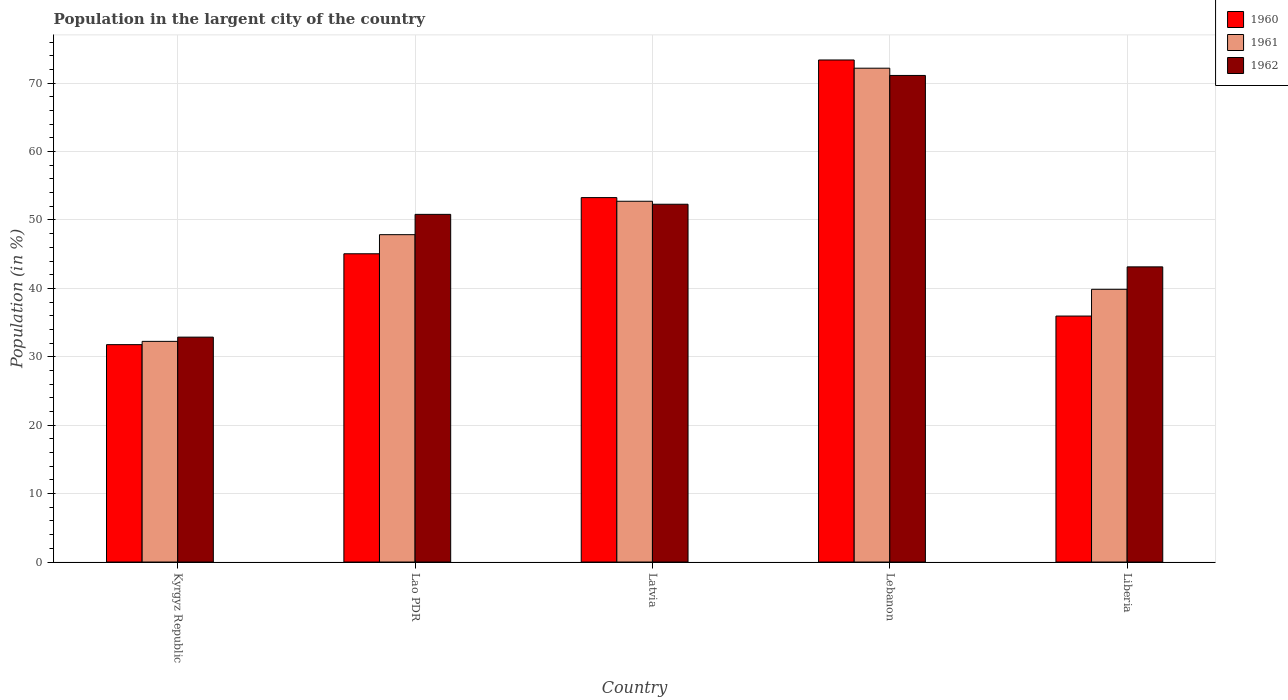How many different coloured bars are there?
Ensure brevity in your answer.  3. How many groups of bars are there?
Offer a very short reply. 5. Are the number of bars per tick equal to the number of legend labels?
Offer a very short reply. Yes. What is the label of the 1st group of bars from the left?
Keep it short and to the point. Kyrgyz Republic. In how many cases, is the number of bars for a given country not equal to the number of legend labels?
Ensure brevity in your answer.  0. What is the percentage of population in the largent city in 1962 in Latvia?
Your response must be concise. 52.3. Across all countries, what is the maximum percentage of population in the largent city in 1961?
Your answer should be compact. 72.19. Across all countries, what is the minimum percentage of population in the largent city in 1960?
Ensure brevity in your answer.  31.78. In which country was the percentage of population in the largent city in 1960 maximum?
Provide a short and direct response. Lebanon. In which country was the percentage of population in the largent city in 1962 minimum?
Provide a short and direct response. Kyrgyz Republic. What is the total percentage of population in the largent city in 1962 in the graph?
Provide a succinct answer. 250.28. What is the difference between the percentage of population in the largent city in 1960 in Lao PDR and that in Latvia?
Provide a succinct answer. -8.21. What is the difference between the percentage of population in the largent city in 1961 in Liberia and the percentage of population in the largent city in 1962 in Latvia?
Offer a terse response. -12.43. What is the average percentage of population in the largent city in 1960 per country?
Offer a very short reply. 47.89. What is the difference between the percentage of population in the largent city of/in 1961 and percentage of population in the largent city of/in 1960 in Kyrgyz Republic?
Offer a terse response. 0.48. What is the ratio of the percentage of population in the largent city in 1962 in Lao PDR to that in Liberia?
Your response must be concise. 1.18. Is the difference between the percentage of population in the largent city in 1961 in Lao PDR and Lebanon greater than the difference between the percentage of population in the largent city in 1960 in Lao PDR and Lebanon?
Keep it short and to the point. Yes. What is the difference between the highest and the second highest percentage of population in the largent city in 1960?
Give a very brief answer. 28.33. What is the difference between the highest and the lowest percentage of population in the largent city in 1960?
Provide a short and direct response. 41.61. In how many countries, is the percentage of population in the largent city in 1960 greater than the average percentage of population in the largent city in 1960 taken over all countries?
Keep it short and to the point. 2. Is the sum of the percentage of population in the largent city in 1961 in Latvia and Lebanon greater than the maximum percentage of population in the largent city in 1962 across all countries?
Make the answer very short. Yes. What does the 2nd bar from the left in Kyrgyz Republic represents?
Provide a succinct answer. 1961. How many bars are there?
Keep it short and to the point. 15. What is the difference between two consecutive major ticks on the Y-axis?
Make the answer very short. 10. Are the values on the major ticks of Y-axis written in scientific E-notation?
Keep it short and to the point. No. How many legend labels are there?
Your answer should be very brief. 3. How are the legend labels stacked?
Ensure brevity in your answer.  Vertical. What is the title of the graph?
Offer a very short reply. Population in the largent city of the country. What is the Population (in %) in 1960 in Kyrgyz Republic?
Provide a succinct answer. 31.78. What is the Population (in %) of 1961 in Kyrgyz Republic?
Keep it short and to the point. 32.26. What is the Population (in %) in 1962 in Kyrgyz Republic?
Ensure brevity in your answer.  32.88. What is the Population (in %) of 1960 in Lao PDR?
Make the answer very short. 45.06. What is the Population (in %) of 1961 in Lao PDR?
Give a very brief answer. 47.86. What is the Population (in %) of 1962 in Lao PDR?
Give a very brief answer. 50.82. What is the Population (in %) in 1960 in Latvia?
Your answer should be very brief. 53.27. What is the Population (in %) of 1961 in Latvia?
Give a very brief answer. 52.74. What is the Population (in %) of 1962 in Latvia?
Provide a succinct answer. 52.3. What is the Population (in %) of 1960 in Lebanon?
Make the answer very short. 73.39. What is the Population (in %) in 1961 in Lebanon?
Make the answer very short. 72.19. What is the Population (in %) in 1962 in Lebanon?
Ensure brevity in your answer.  71.13. What is the Population (in %) of 1960 in Liberia?
Provide a succinct answer. 35.96. What is the Population (in %) of 1961 in Liberia?
Give a very brief answer. 39.87. What is the Population (in %) of 1962 in Liberia?
Provide a succinct answer. 43.15. Across all countries, what is the maximum Population (in %) of 1960?
Make the answer very short. 73.39. Across all countries, what is the maximum Population (in %) of 1961?
Your answer should be very brief. 72.19. Across all countries, what is the maximum Population (in %) of 1962?
Give a very brief answer. 71.13. Across all countries, what is the minimum Population (in %) in 1960?
Make the answer very short. 31.78. Across all countries, what is the minimum Population (in %) in 1961?
Your answer should be compact. 32.26. Across all countries, what is the minimum Population (in %) of 1962?
Ensure brevity in your answer.  32.88. What is the total Population (in %) in 1960 in the graph?
Offer a terse response. 239.46. What is the total Population (in %) in 1961 in the graph?
Keep it short and to the point. 244.91. What is the total Population (in %) in 1962 in the graph?
Provide a short and direct response. 250.28. What is the difference between the Population (in %) of 1960 in Kyrgyz Republic and that in Lao PDR?
Your response must be concise. -13.28. What is the difference between the Population (in %) in 1961 in Kyrgyz Republic and that in Lao PDR?
Ensure brevity in your answer.  -15.6. What is the difference between the Population (in %) of 1962 in Kyrgyz Republic and that in Lao PDR?
Provide a short and direct response. -17.95. What is the difference between the Population (in %) in 1960 in Kyrgyz Republic and that in Latvia?
Your answer should be very brief. -21.5. What is the difference between the Population (in %) of 1961 in Kyrgyz Republic and that in Latvia?
Your response must be concise. -20.48. What is the difference between the Population (in %) of 1962 in Kyrgyz Republic and that in Latvia?
Your answer should be very brief. -19.42. What is the difference between the Population (in %) of 1960 in Kyrgyz Republic and that in Lebanon?
Offer a very short reply. -41.61. What is the difference between the Population (in %) of 1961 in Kyrgyz Republic and that in Lebanon?
Keep it short and to the point. -39.93. What is the difference between the Population (in %) of 1962 in Kyrgyz Republic and that in Lebanon?
Provide a succinct answer. -38.25. What is the difference between the Population (in %) in 1960 in Kyrgyz Republic and that in Liberia?
Keep it short and to the point. -4.18. What is the difference between the Population (in %) of 1961 in Kyrgyz Republic and that in Liberia?
Ensure brevity in your answer.  -7.61. What is the difference between the Population (in %) in 1962 in Kyrgyz Republic and that in Liberia?
Keep it short and to the point. -10.27. What is the difference between the Population (in %) in 1960 in Lao PDR and that in Latvia?
Give a very brief answer. -8.21. What is the difference between the Population (in %) of 1961 in Lao PDR and that in Latvia?
Ensure brevity in your answer.  -4.88. What is the difference between the Population (in %) in 1962 in Lao PDR and that in Latvia?
Make the answer very short. -1.48. What is the difference between the Population (in %) of 1960 in Lao PDR and that in Lebanon?
Offer a very short reply. -28.33. What is the difference between the Population (in %) of 1961 in Lao PDR and that in Lebanon?
Offer a terse response. -24.34. What is the difference between the Population (in %) in 1962 in Lao PDR and that in Lebanon?
Your answer should be very brief. -20.31. What is the difference between the Population (in %) in 1960 in Lao PDR and that in Liberia?
Offer a terse response. 9.1. What is the difference between the Population (in %) in 1961 in Lao PDR and that in Liberia?
Provide a short and direct response. 7.99. What is the difference between the Population (in %) in 1962 in Lao PDR and that in Liberia?
Your answer should be very brief. 7.67. What is the difference between the Population (in %) in 1960 in Latvia and that in Lebanon?
Ensure brevity in your answer.  -20.12. What is the difference between the Population (in %) in 1961 in Latvia and that in Lebanon?
Keep it short and to the point. -19.45. What is the difference between the Population (in %) in 1962 in Latvia and that in Lebanon?
Keep it short and to the point. -18.83. What is the difference between the Population (in %) of 1960 in Latvia and that in Liberia?
Provide a short and direct response. 17.32. What is the difference between the Population (in %) of 1961 in Latvia and that in Liberia?
Give a very brief answer. 12.87. What is the difference between the Population (in %) of 1962 in Latvia and that in Liberia?
Your answer should be compact. 9.15. What is the difference between the Population (in %) in 1960 in Lebanon and that in Liberia?
Give a very brief answer. 37.43. What is the difference between the Population (in %) in 1961 in Lebanon and that in Liberia?
Your answer should be very brief. 32.32. What is the difference between the Population (in %) of 1962 in Lebanon and that in Liberia?
Offer a terse response. 27.98. What is the difference between the Population (in %) of 1960 in Kyrgyz Republic and the Population (in %) of 1961 in Lao PDR?
Keep it short and to the point. -16.08. What is the difference between the Population (in %) of 1960 in Kyrgyz Republic and the Population (in %) of 1962 in Lao PDR?
Provide a succinct answer. -19.05. What is the difference between the Population (in %) of 1961 in Kyrgyz Republic and the Population (in %) of 1962 in Lao PDR?
Keep it short and to the point. -18.57. What is the difference between the Population (in %) in 1960 in Kyrgyz Republic and the Population (in %) in 1961 in Latvia?
Offer a very short reply. -20.96. What is the difference between the Population (in %) of 1960 in Kyrgyz Republic and the Population (in %) of 1962 in Latvia?
Your answer should be compact. -20.52. What is the difference between the Population (in %) in 1961 in Kyrgyz Republic and the Population (in %) in 1962 in Latvia?
Provide a succinct answer. -20.04. What is the difference between the Population (in %) of 1960 in Kyrgyz Republic and the Population (in %) of 1961 in Lebanon?
Make the answer very short. -40.41. What is the difference between the Population (in %) in 1960 in Kyrgyz Republic and the Population (in %) in 1962 in Lebanon?
Your answer should be compact. -39.35. What is the difference between the Population (in %) of 1961 in Kyrgyz Republic and the Population (in %) of 1962 in Lebanon?
Offer a terse response. -38.87. What is the difference between the Population (in %) in 1960 in Kyrgyz Republic and the Population (in %) in 1961 in Liberia?
Provide a short and direct response. -8.09. What is the difference between the Population (in %) in 1960 in Kyrgyz Republic and the Population (in %) in 1962 in Liberia?
Offer a very short reply. -11.37. What is the difference between the Population (in %) in 1961 in Kyrgyz Republic and the Population (in %) in 1962 in Liberia?
Provide a succinct answer. -10.89. What is the difference between the Population (in %) of 1960 in Lao PDR and the Population (in %) of 1961 in Latvia?
Provide a short and direct response. -7.68. What is the difference between the Population (in %) of 1960 in Lao PDR and the Population (in %) of 1962 in Latvia?
Offer a very short reply. -7.24. What is the difference between the Population (in %) in 1961 in Lao PDR and the Population (in %) in 1962 in Latvia?
Offer a terse response. -4.45. What is the difference between the Population (in %) of 1960 in Lao PDR and the Population (in %) of 1961 in Lebanon?
Give a very brief answer. -27.13. What is the difference between the Population (in %) in 1960 in Lao PDR and the Population (in %) in 1962 in Lebanon?
Your answer should be very brief. -26.07. What is the difference between the Population (in %) in 1961 in Lao PDR and the Population (in %) in 1962 in Lebanon?
Offer a terse response. -23.28. What is the difference between the Population (in %) of 1960 in Lao PDR and the Population (in %) of 1961 in Liberia?
Offer a terse response. 5.19. What is the difference between the Population (in %) of 1960 in Lao PDR and the Population (in %) of 1962 in Liberia?
Offer a terse response. 1.91. What is the difference between the Population (in %) of 1961 in Lao PDR and the Population (in %) of 1962 in Liberia?
Your response must be concise. 4.71. What is the difference between the Population (in %) in 1960 in Latvia and the Population (in %) in 1961 in Lebanon?
Offer a very short reply. -18.92. What is the difference between the Population (in %) of 1960 in Latvia and the Population (in %) of 1962 in Lebanon?
Ensure brevity in your answer.  -17.86. What is the difference between the Population (in %) of 1961 in Latvia and the Population (in %) of 1962 in Lebanon?
Your response must be concise. -18.39. What is the difference between the Population (in %) of 1960 in Latvia and the Population (in %) of 1961 in Liberia?
Ensure brevity in your answer.  13.41. What is the difference between the Population (in %) in 1960 in Latvia and the Population (in %) in 1962 in Liberia?
Keep it short and to the point. 10.13. What is the difference between the Population (in %) in 1961 in Latvia and the Population (in %) in 1962 in Liberia?
Your response must be concise. 9.59. What is the difference between the Population (in %) in 1960 in Lebanon and the Population (in %) in 1961 in Liberia?
Provide a short and direct response. 33.52. What is the difference between the Population (in %) of 1960 in Lebanon and the Population (in %) of 1962 in Liberia?
Your answer should be very brief. 30.24. What is the difference between the Population (in %) of 1961 in Lebanon and the Population (in %) of 1962 in Liberia?
Provide a short and direct response. 29.04. What is the average Population (in %) in 1960 per country?
Make the answer very short. 47.89. What is the average Population (in %) of 1961 per country?
Ensure brevity in your answer.  48.98. What is the average Population (in %) in 1962 per country?
Provide a succinct answer. 50.06. What is the difference between the Population (in %) in 1960 and Population (in %) in 1961 in Kyrgyz Republic?
Your answer should be very brief. -0.48. What is the difference between the Population (in %) in 1960 and Population (in %) in 1962 in Kyrgyz Republic?
Your answer should be compact. -1.1. What is the difference between the Population (in %) in 1961 and Population (in %) in 1962 in Kyrgyz Republic?
Ensure brevity in your answer.  -0.62. What is the difference between the Population (in %) of 1960 and Population (in %) of 1961 in Lao PDR?
Your answer should be very brief. -2.79. What is the difference between the Population (in %) of 1960 and Population (in %) of 1962 in Lao PDR?
Make the answer very short. -5.76. What is the difference between the Population (in %) in 1961 and Population (in %) in 1962 in Lao PDR?
Your answer should be compact. -2.97. What is the difference between the Population (in %) of 1960 and Population (in %) of 1961 in Latvia?
Keep it short and to the point. 0.53. What is the difference between the Population (in %) of 1960 and Population (in %) of 1962 in Latvia?
Give a very brief answer. 0.97. What is the difference between the Population (in %) in 1961 and Population (in %) in 1962 in Latvia?
Your answer should be compact. 0.44. What is the difference between the Population (in %) of 1960 and Population (in %) of 1961 in Lebanon?
Keep it short and to the point. 1.2. What is the difference between the Population (in %) in 1960 and Population (in %) in 1962 in Lebanon?
Your response must be concise. 2.26. What is the difference between the Population (in %) of 1961 and Population (in %) of 1962 in Lebanon?
Your response must be concise. 1.06. What is the difference between the Population (in %) in 1960 and Population (in %) in 1961 in Liberia?
Make the answer very short. -3.91. What is the difference between the Population (in %) in 1960 and Population (in %) in 1962 in Liberia?
Ensure brevity in your answer.  -7.19. What is the difference between the Population (in %) of 1961 and Population (in %) of 1962 in Liberia?
Ensure brevity in your answer.  -3.28. What is the ratio of the Population (in %) of 1960 in Kyrgyz Republic to that in Lao PDR?
Offer a very short reply. 0.71. What is the ratio of the Population (in %) of 1961 in Kyrgyz Republic to that in Lao PDR?
Make the answer very short. 0.67. What is the ratio of the Population (in %) in 1962 in Kyrgyz Republic to that in Lao PDR?
Your answer should be very brief. 0.65. What is the ratio of the Population (in %) of 1960 in Kyrgyz Republic to that in Latvia?
Give a very brief answer. 0.6. What is the ratio of the Population (in %) of 1961 in Kyrgyz Republic to that in Latvia?
Provide a succinct answer. 0.61. What is the ratio of the Population (in %) in 1962 in Kyrgyz Republic to that in Latvia?
Provide a short and direct response. 0.63. What is the ratio of the Population (in %) of 1960 in Kyrgyz Republic to that in Lebanon?
Your answer should be compact. 0.43. What is the ratio of the Population (in %) in 1961 in Kyrgyz Republic to that in Lebanon?
Keep it short and to the point. 0.45. What is the ratio of the Population (in %) in 1962 in Kyrgyz Republic to that in Lebanon?
Your answer should be very brief. 0.46. What is the ratio of the Population (in %) in 1960 in Kyrgyz Republic to that in Liberia?
Offer a very short reply. 0.88. What is the ratio of the Population (in %) in 1961 in Kyrgyz Republic to that in Liberia?
Offer a terse response. 0.81. What is the ratio of the Population (in %) of 1962 in Kyrgyz Republic to that in Liberia?
Make the answer very short. 0.76. What is the ratio of the Population (in %) of 1960 in Lao PDR to that in Latvia?
Your answer should be compact. 0.85. What is the ratio of the Population (in %) of 1961 in Lao PDR to that in Latvia?
Your answer should be compact. 0.91. What is the ratio of the Population (in %) of 1962 in Lao PDR to that in Latvia?
Provide a short and direct response. 0.97. What is the ratio of the Population (in %) in 1960 in Lao PDR to that in Lebanon?
Offer a terse response. 0.61. What is the ratio of the Population (in %) in 1961 in Lao PDR to that in Lebanon?
Offer a terse response. 0.66. What is the ratio of the Population (in %) in 1962 in Lao PDR to that in Lebanon?
Give a very brief answer. 0.71. What is the ratio of the Population (in %) of 1960 in Lao PDR to that in Liberia?
Offer a very short reply. 1.25. What is the ratio of the Population (in %) of 1961 in Lao PDR to that in Liberia?
Provide a succinct answer. 1.2. What is the ratio of the Population (in %) in 1962 in Lao PDR to that in Liberia?
Offer a terse response. 1.18. What is the ratio of the Population (in %) in 1960 in Latvia to that in Lebanon?
Provide a succinct answer. 0.73. What is the ratio of the Population (in %) in 1961 in Latvia to that in Lebanon?
Keep it short and to the point. 0.73. What is the ratio of the Population (in %) in 1962 in Latvia to that in Lebanon?
Ensure brevity in your answer.  0.74. What is the ratio of the Population (in %) of 1960 in Latvia to that in Liberia?
Your answer should be very brief. 1.48. What is the ratio of the Population (in %) in 1961 in Latvia to that in Liberia?
Provide a short and direct response. 1.32. What is the ratio of the Population (in %) in 1962 in Latvia to that in Liberia?
Offer a very short reply. 1.21. What is the ratio of the Population (in %) of 1960 in Lebanon to that in Liberia?
Offer a terse response. 2.04. What is the ratio of the Population (in %) of 1961 in Lebanon to that in Liberia?
Give a very brief answer. 1.81. What is the ratio of the Population (in %) in 1962 in Lebanon to that in Liberia?
Your answer should be very brief. 1.65. What is the difference between the highest and the second highest Population (in %) of 1960?
Keep it short and to the point. 20.12. What is the difference between the highest and the second highest Population (in %) in 1961?
Give a very brief answer. 19.45. What is the difference between the highest and the second highest Population (in %) in 1962?
Give a very brief answer. 18.83. What is the difference between the highest and the lowest Population (in %) in 1960?
Offer a very short reply. 41.61. What is the difference between the highest and the lowest Population (in %) of 1961?
Your response must be concise. 39.93. What is the difference between the highest and the lowest Population (in %) of 1962?
Make the answer very short. 38.25. 